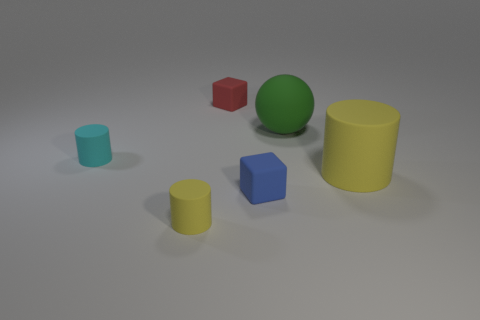Imagine you could interact with these objects. Which one do you think would feel the heaviest if you picked it up? If I were to hypothesize, the large green sphere would likely feel the heaviest to pick up due to its voluminous shape and size, suggesting greater density and mass compared to the other objects, assuming they are all made from the same material. 